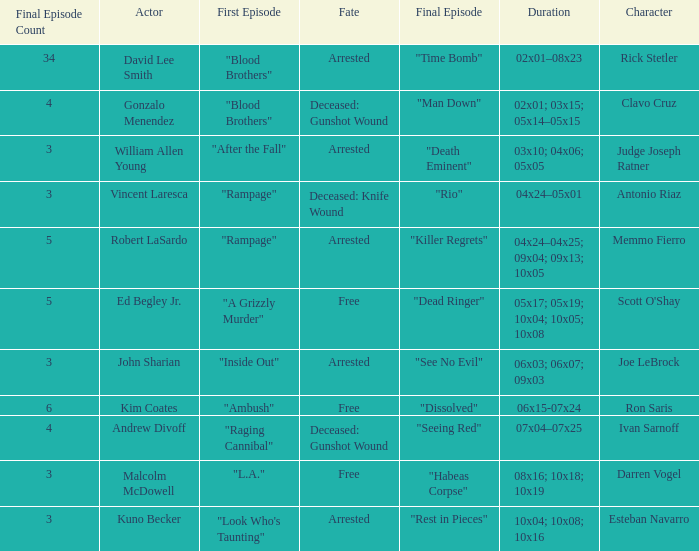What's the first epbeingode with final epbeingode being "rio" "Rampage". 